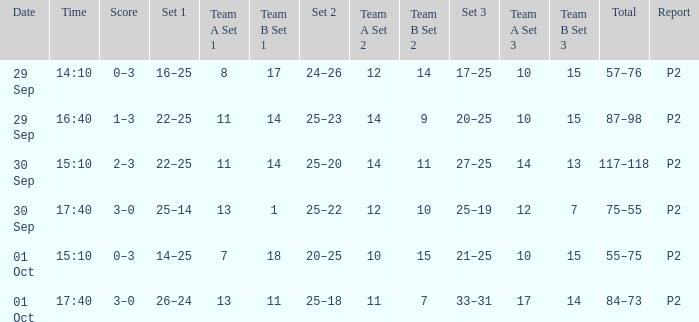For a date of 29 Sep and a time of 16:40, what is the corresponding Set 3? 20–25. 